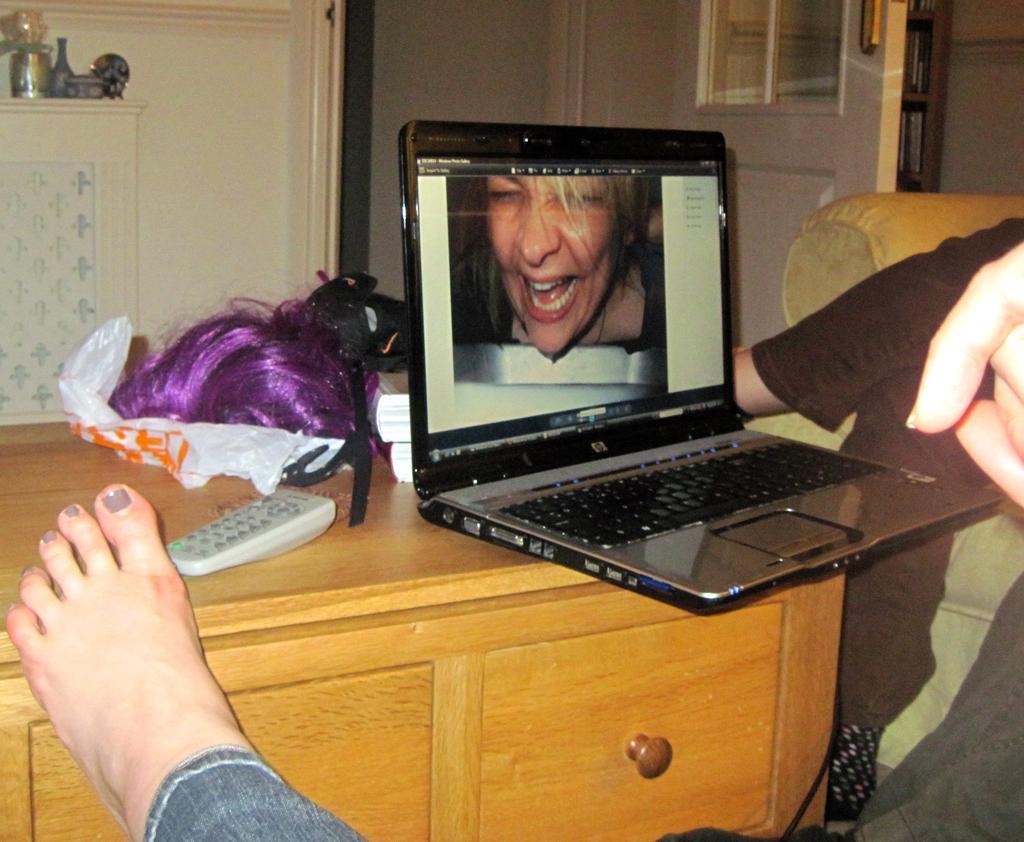How would you summarize this image in a sentence or two? This picture shows a laptop on the table and a leg of a woman 